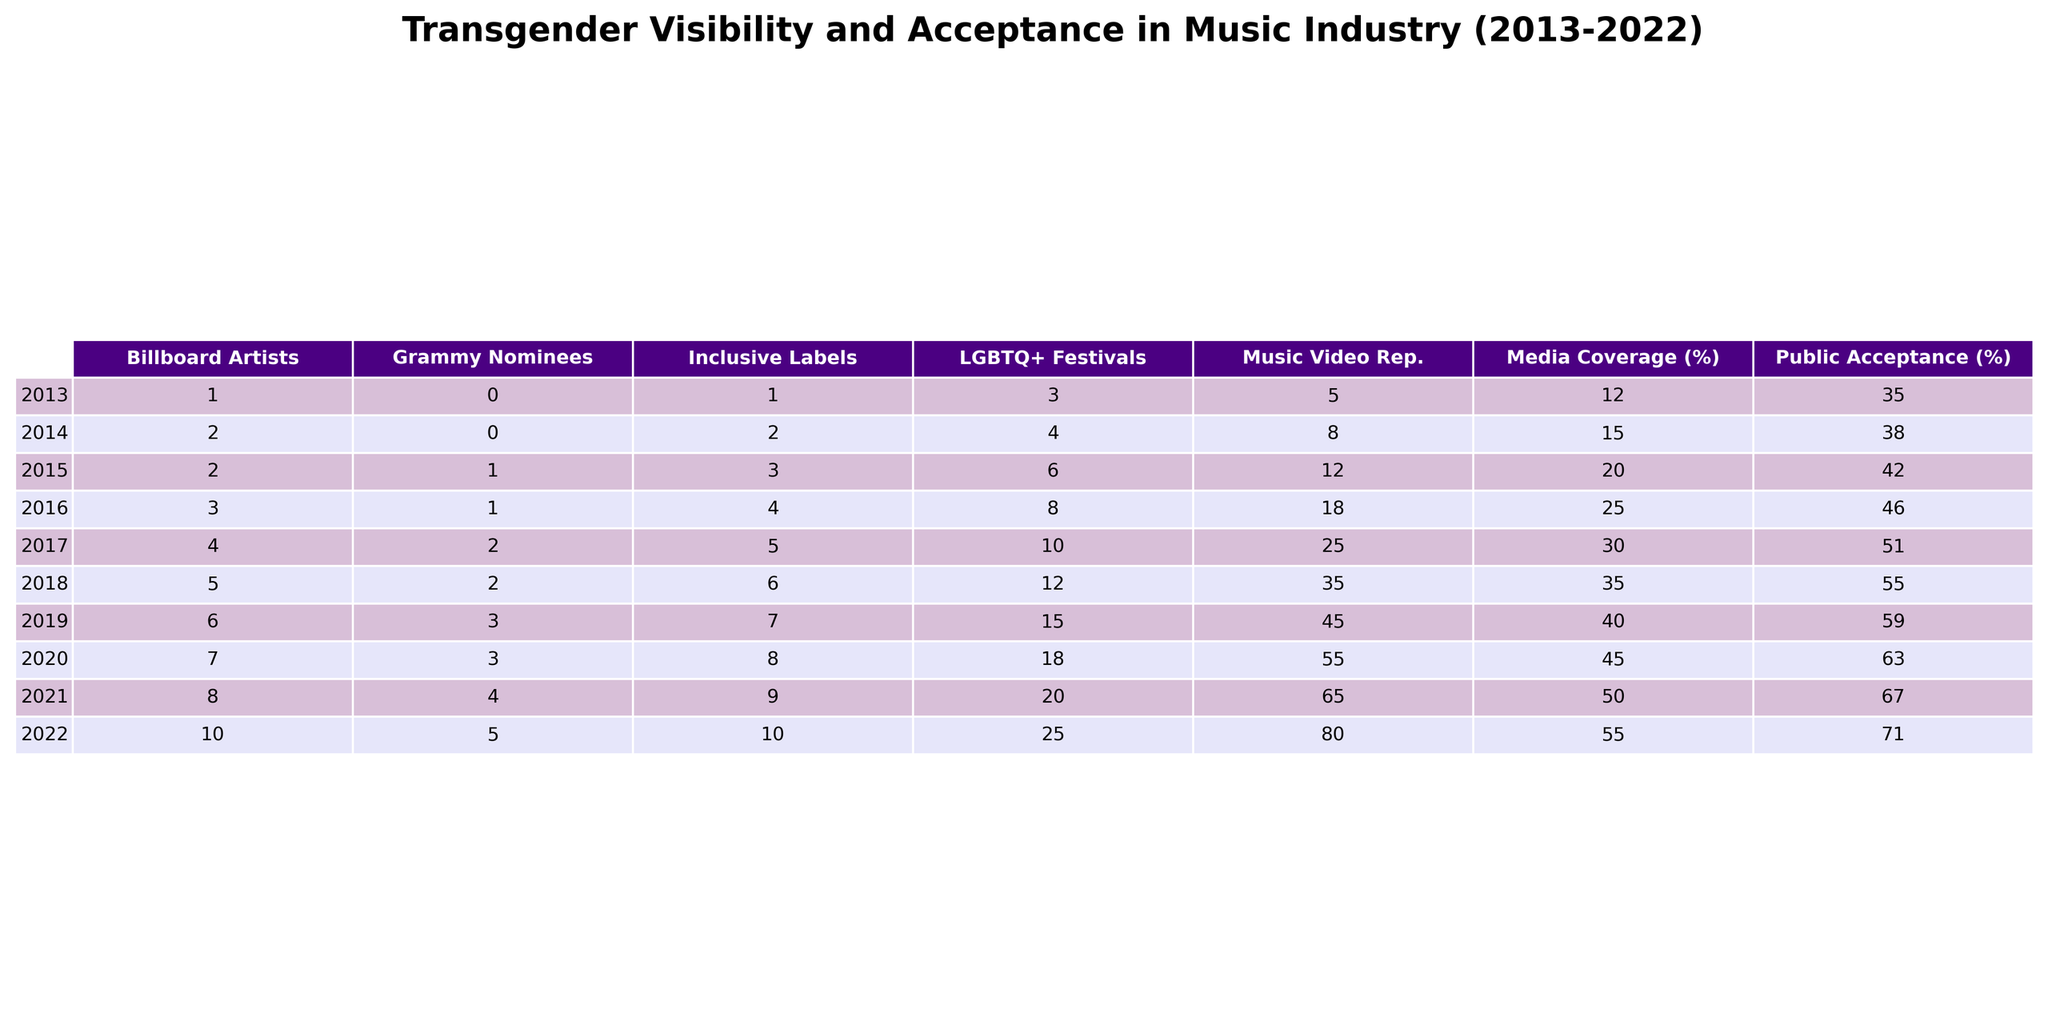What was the public acceptance percentage of trans artists in 2020? The table shows a specific column for public acceptance of trans artists for each year. Looking at the year 2020, the value in that row is 63%.
Answer: 63% How many transgender artists were in the Billboard Hot 100 in 2017? The table provides a column specifically for transgender artists in the Billboard Hot 100. For the year 2017, the value is 4.
Answer: 4 What is the trend in the number of transgender Grammy nominees from 2013 to 2022? By examining the column for transgender Grammy nominees from 2013 to 2022, we see an increase from 0 nominees in 2013 to 5 nominees in 2022. This indicates a positive trend of growth over the years.
Answer: Increasing What is the total number of major labels with trans-inclusive policies by 2022? The table lists the number of major labels with trans-inclusive policies for each year, with 10 being the value for 2022. Therefore, the total number is 10 in that year.
Answer: 10 What was the increase in positive media coverage from 2013 to 2022? Looking at the positive media coverage percentages, we see 12% in 2013 and 55% in 2022. The difference is 55% - 12% = 43%.
Answer: 43% Did the number of LGBTQ+ music festivals always increase from 2013 to 2022? By reviewing the column for LGBTQ+ music festivals, we see the values increase steadily from 3 in 2013 to 25 in 2022, indicating consistent growth each year.
Answer: Yes What was the average increase in public acceptance of trans artists from 2013 to 2022? To find the average increase, we calculate the total increase from 35% in 2013 to 71% in 2022, which is 71% - 35% = 36%. Then, since there are 9 intervals between the 10 years (2013 to 2022), we divide the total increase by 9, so the average increase is 36% / 9 ≈ 4%.
Answer: ~4% In what year did trans representation in music videos surpass 50% positive media coverage? Reviewing the columns for trans representation in music videos and positive media coverage, we see that in 2021, the music videos represent 65% with media coverage of 50%. Therefore, 2021 is the year when representation surpassed that level of media positivity.
Answer: 2021 What year had the highest number of transgender artists in the Billboard Hot 100? The table lists 10 transgender artists in the Billboard Hot 100 in 2022, which is the highest value in that column across all years.
Answer: 2022 What was the difference in the number of transgender artists between 2019 and 2020? In 2019, there were 6 transgender artists, and in 2020, there were 7. The difference is calculated as 7 - 6 = 1.
Answer: 1 